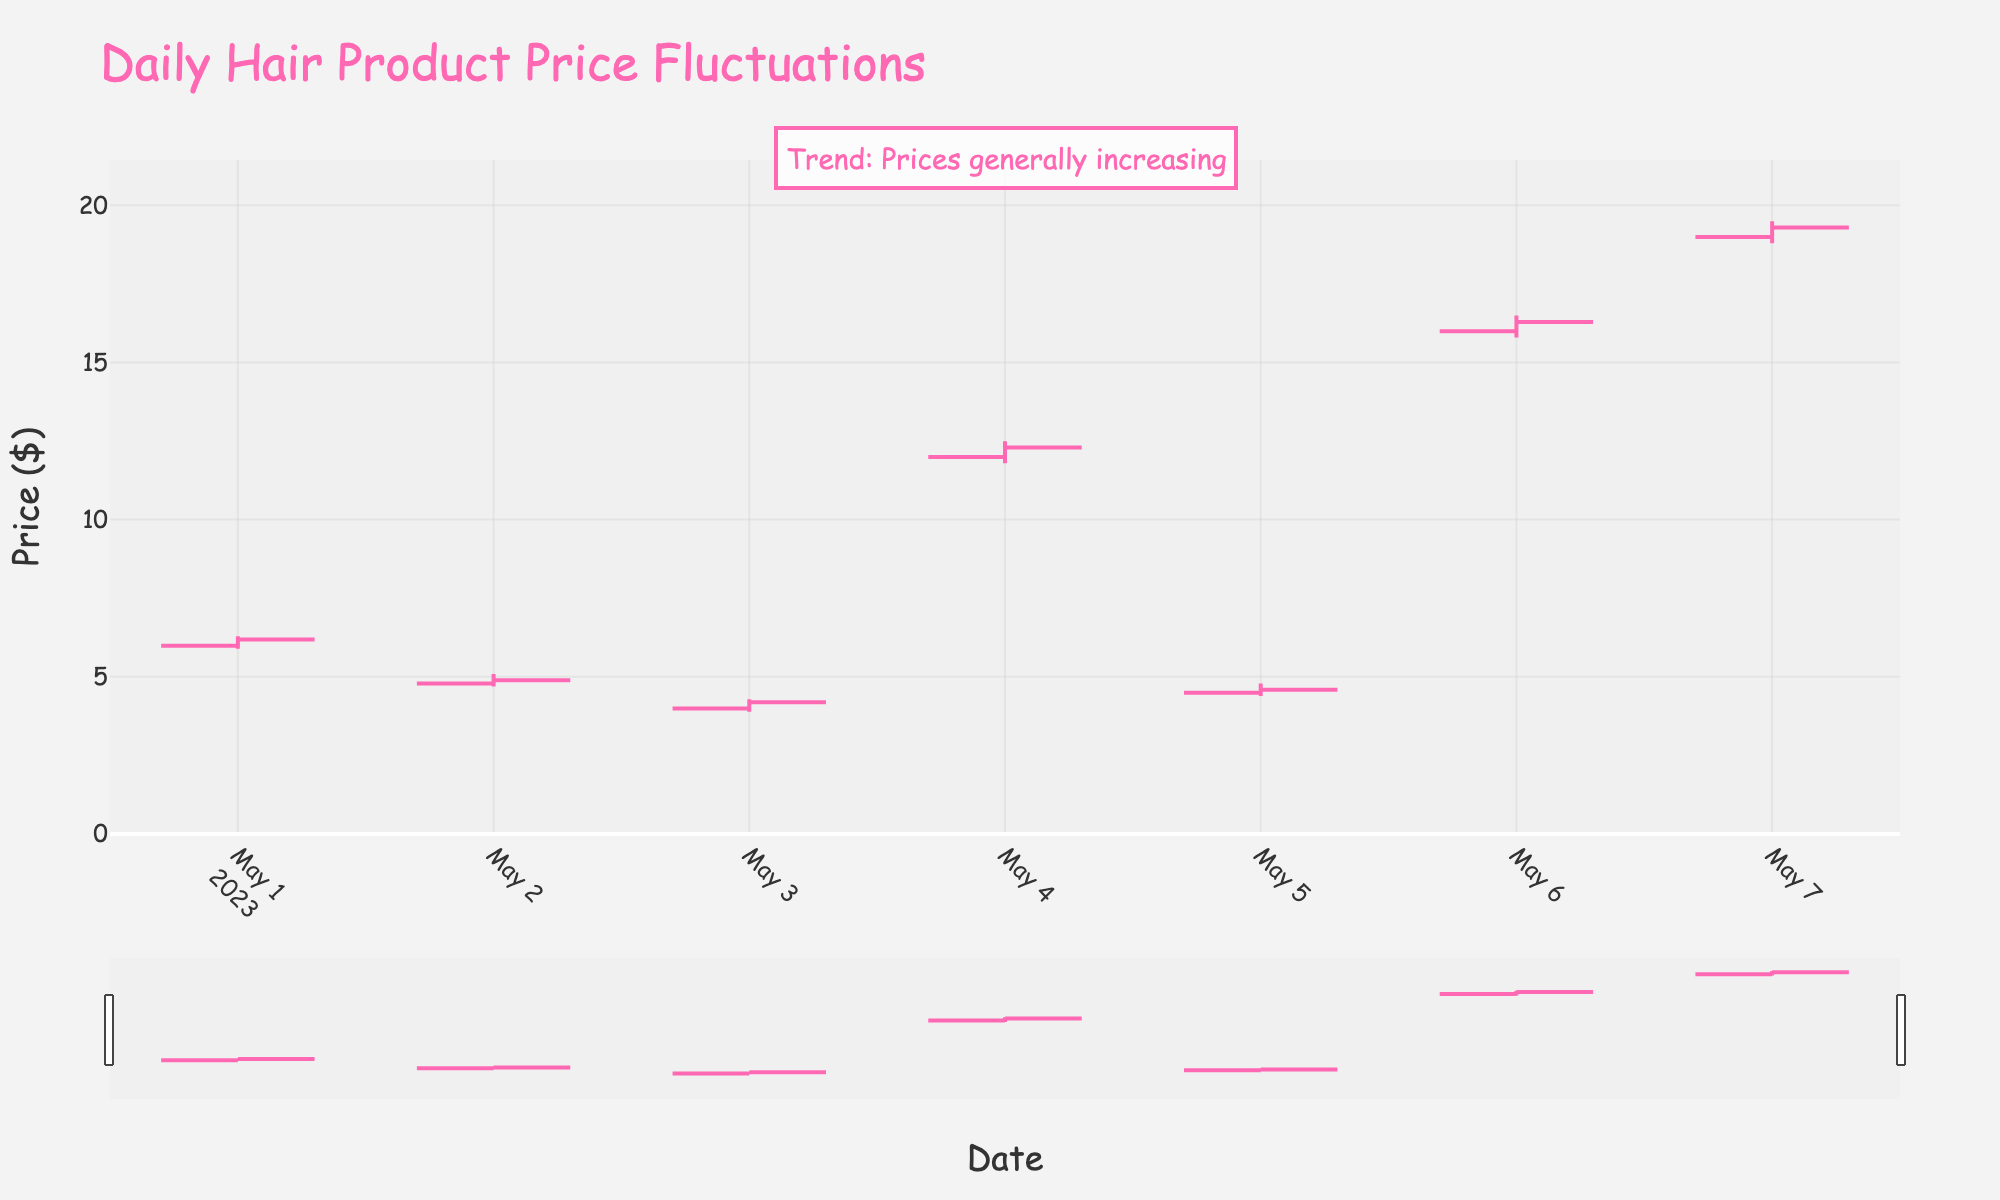What's the title of the figure? The title is located at the top of the figure and states the main subject of the plot. In this case, the title is "Daily Hair Product Price Fluctuations."
Answer: Daily Hair Product Price Fluctuations What are the highest and lowest prices reached in the provided data? To find the highest and lowest prices, look at the 'High' and 'Low' columns in the dataset. The highest price is $19.49 on May 7th for Paul Mitchell Super Skinny Serum. The lowest price is $3.89 on May 3rd for Got2b Glued Styling Gel.
Answer: $19.49, $3.89 Which day had the greatest price increase from open to close? To find the greatest increase, calculate the difference between the open and close prices for each day. Compare these differences across all days. May 4th for L'Oréal Paris Elnett Satin Hairspray had the largest increase ($0.30).
Answer: May 4th Which product had the smallest price range (high minus low)? To determine the smallest price range, subtract the 'Low' price from the 'High' price for each product and compare the values. The TRESemmé Extra Hold Hairspray on May 2nd had the smallest range with a difference of $0.40.
Answer: TRESemmé Extra Hold Hairspray Did any product have a continuous increase in closing prices throughout the dataset? Check the 'Close' prices from each day and see if there are any products where the closing price increases every single day. Only Paul Mitchell Super Skinny Serum (May 7th) shows an increase from the 'Open' to the 'Close' price, but no product increases continuously day by day.
Answer: No How many days did the Garnier Fructis Sleek & Shine Serum close lower than it opened? For the Garnier Fructis Sleek & Shine Serum, compare the 'Open' and 'Close' prices on each day it appears. It closed higher than it opened on May 1st.
Answer: 1 day What is the difference in closing prices between Garnier Fructis Sleek & Shine Serum and Bed Head After Party Smoothing Cream on their respective days? Compare the closing price of Garnier Fructis Sleek & Shine Serum on May 1st ($6.19) with the closing price of Bed Head After Party Smoothing Cream on May 6th ($16.29). The difference is $16.29 - $6.19 = $10.10.
Answer: $10.10 Which product has the highest opening price and on which date? Look at the 'Open' column for each product and identify the highest value and its corresponding date. The highest opening price is $18.99 for Paul Mitchell Super Skinny Serum on May 7th.
Answer: Paul Mitchell Super Skinny Serum, May 7th What trend annotation is included in the figure? The annotation in the figure text details the general trend observed. The annotation states, "Trend: Prices generally increasing."
Answer: Prices generally increasing By what amount did the closing price of Aussie Miracle Curls Mousse differ from its opening price on May 5th? Subtract the 'Open' price from the 'Close' price for Aussie Miracle Curls Mousse on May 5th (Close: $4.59, Open: $4.49). The difference is $4.59 - $4.49 = $0.10.
Answer: $0.10 